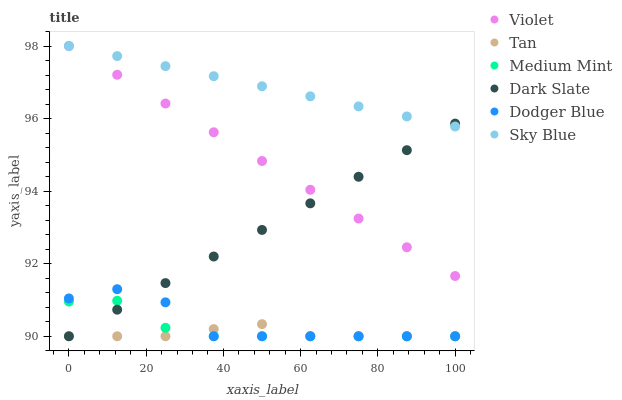Does Tan have the minimum area under the curve?
Answer yes or no. Yes. Does Sky Blue have the maximum area under the curve?
Answer yes or no. Yes. Does Dark Slate have the minimum area under the curve?
Answer yes or no. No. Does Dark Slate have the maximum area under the curve?
Answer yes or no. No. Is Sky Blue the smoothest?
Answer yes or no. Yes. Is Dodger Blue the roughest?
Answer yes or no. Yes. Is Dark Slate the smoothest?
Answer yes or no. No. Is Dark Slate the roughest?
Answer yes or no. No. Does Medium Mint have the lowest value?
Answer yes or no. Yes. Does Violet have the lowest value?
Answer yes or no. No. Does Sky Blue have the highest value?
Answer yes or no. Yes. Does Dark Slate have the highest value?
Answer yes or no. No. Is Tan less than Violet?
Answer yes or no. Yes. Is Sky Blue greater than Medium Mint?
Answer yes or no. Yes. Does Dark Slate intersect Sky Blue?
Answer yes or no. Yes. Is Dark Slate less than Sky Blue?
Answer yes or no. No. Is Dark Slate greater than Sky Blue?
Answer yes or no. No. Does Tan intersect Violet?
Answer yes or no. No. 